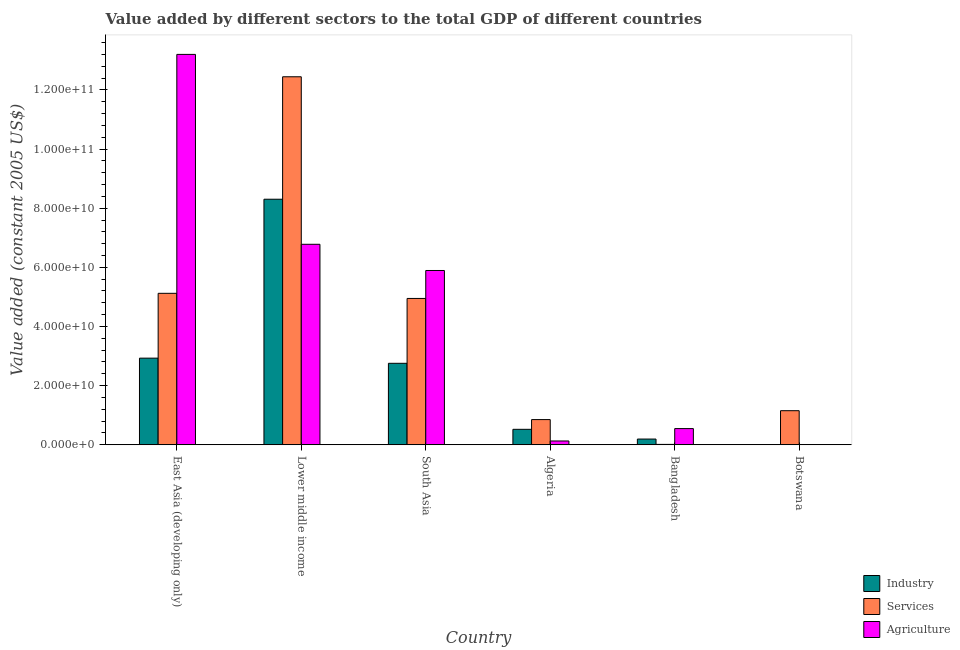How many groups of bars are there?
Make the answer very short. 6. Are the number of bars on each tick of the X-axis equal?
Your response must be concise. Yes. How many bars are there on the 6th tick from the left?
Keep it short and to the point. 3. What is the label of the 1st group of bars from the left?
Ensure brevity in your answer.  East Asia (developing only). In how many cases, is the number of bars for a given country not equal to the number of legend labels?
Make the answer very short. 0. What is the value added by services in South Asia?
Keep it short and to the point. 4.95e+1. Across all countries, what is the maximum value added by services?
Offer a terse response. 1.24e+11. Across all countries, what is the minimum value added by industrial sector?
Provide a succinct answer. 1.98e+07. In which country was the value added by industrial sector maximum?
Your answer should be very brief. Lower middle income. In which country was the value added by agricultural sector minimum?
Your response must be concise. Botswana. What is the total value added by industrial sector in the graph?
Offer a terse response. 1.47e+11. What is the difference between the value added by industrial sector in Lower middle income and that in South Asia?
Provide a succinct answer. 5.55e+1. What is the difference between the value added by services in East Asia (developing only) and the value added by agricultural sector in Botswana?
Keep it short and to the point. 5.12e+1. What is the average value added by services per country?
Ensure brevity in your answer.  4.09e+1. What is the difference between the value added by services and value added by industrial sector in Lower middle income?
Your answer should be very brief. 4.14e+1. What is the ratio of the value added by agricultural sector in Bangladesh to that in East Asia (developing only)?
Offer a very short reply. 0.04. Is the value added by services in Lower middle income less than that in South Asia?
Your answer should be compact. No. Is the difference between the value added by services in Bangladesh and East Asia (developing only) greater than the difference between the value added by industrial sector in Bangladesh and East Asia (developing only)?
Offer a very short reply. No. What is the difference between the highest and the second highest value added by industrial sector?
Keep it short and to the point. 5.37e+1. What is the difference between the highest and the lowest value added by services?
Your response must be concise. 1.24e+11. In how many countries, is the value added by industrial sector greater than the average value added by industrial sector taken over all countries?
Provide a succinct answer. 3. Is the sum of the value added by agricultural sector in Algeria and East Asia (developing only) greater than the maximum value added by services across all countries?
Provide a succinct answer. Yes. What does the 3rd bar from the left in East Asia (developing only) represents?
Your answer should be compact. Agriculture. What does the 3rd bar from the right in Lower middle income represents?
Your response must be concise. Industry. How many bars are there?
Make the answer very short. 18. Are all the bars in the graph horizontal?
Keep it short and to the point. No. How many countries are there in the graph?
Your answer should be compact. 6. What is the difference between two consecutive major ticks on the Y-axis?
Give a very brief answer. 2.00e+1. Are the values on the major ticks of Y-axis written in scientific E-notation?
Make the answer very short. Yes. Does the graph contain any zero values?
Offer a terse response. No. Where does the legend appear in the graph?
Ensure brevity in your answer.  Bottom right. How are the legend labels stacked?
Your response must be concise. Vertical. What is the title of the graph?
Offer a very short reply. Value added by different sectors to the total GDP of different countries. Does "Ages 15-20" appear as one of the legend labels in the graph?
Make the answer very short. No. What is the label or title of the Y-axis?
Ensure brevity in your answer.  Value added (constant 2005 US$). What is the Value added (constant 2005 US$) in Industry in East Asia (developing only)?
Your answer should be very brief. 2.93e+1. What is the Value added (constant 2005 US$) of Services in East Asia (developing only)?
Provide a succinct answer. 5.12e+1. What is the Value added (constant 2005 US$) in Agriculture in East Asia (developing only)?
Provide a short and direct response. 1.32e+11. What is the Value added (constant 2005 US$) of Industry in Lower middle income?
Provide a succinct answer. 8.30e+1. What is the Value added (constant 2005 US$) in Services in Lower middle income?
Ensure brevity in your answer.  1.24e+11. What is the Value added (constant 2005 US$) of Agriculture in Lower middle income?
Offer a terse response. 6.78e+1. What is the Value added (constant 2005 US$) of Industry in South Asia?
Your answer should be compact. 2.76e+1. What is the Value added (constant 2005 US$) in Services in South Asia?
Provide a short and direct response. 4.95e+1. What is the Value added (constant 2005 US$) in Agriculture in South Asia?
Give a very brief answer. 5.89e+1. What is the Value added (constant 2005 US$) in Industry in Algeria?
Make the answer very short. 5.23e+09. What is the Value added (constant 2005 US$) of Services in Algeria?
Your answer should be very brief. 8.52e+09. What is the Value added (constant 2005 US$) in Agriculture in Algeria?
Provide a short and direct response. 1.29e+09. What is the Value added (constant 2005 US$) in Industry in Bangladesh?
Your response must be concise. 1.94e+09. What is the Value added (constant 2005 US$) in Services in Bangladesh?
Your answer should be very brief. 1.32e+08. What is the Value added (constant 2005 US$) of Agriculture in Bangladesh?
Offer a terse response. 5.48e+09. What is the Value added (constant 2005 US$) in Industry in Botswana?
Give a very brief answer. 1.98e+07. What is the Value added (constant 2005 US$) of Services in Botswana?
Provide a short and direct response. 1.15e+1. What is the Value added (constant 2005 US$) in Agriculture in Botswana?
Keep it short and to the point. 5.04e+07. Across all countries, what is the maximum Value added (constant 2005 US$) of Industry?
Offer a very short reply. 8.30e+1. Across all countries, what is the maximum Value added (constant 2005 US$) of Services?
Keep it short and to the point. 1.24e+11. Across all countries, what is the maximum Value added (constant 2005 US$) in Agriculture?
Offer a terse response. 1.32e+11. Across all countries, what is the minimum Value added (constant 2005 US$) in Industry?
Your answer should be very brief. 1.98e+07. Across all countries, what is the minimum Value added (constant 2005 US$) of Services?
Your response must be concise. 1.32e+08. Across all countries, what is the minimum Value added (constant 2005 US$) of Agriculture?
Offer a very short reply. 5.04e+07. What is the total Value added (constant 2005 US$) of Industry in the graph?
Offer a very short reply. 1.47e+11. What is the total Value added (constant 2005 US$) in Services in the graph?
Provide a short and direct response. 2.45e+11. What is the total Value added (constant 2005 US$) in Agriculture in the graph?
Your answer should be very brief. 2.66e+11. What is the difference between the Value added (constant 2005 US$) of Industry in East Asia (developing only) and that in Lower middle income?
Ensure brevity in your answer.  -5.37e+1. What is the difference between the Value added (constant 2005 US$) of Services in East Asia (developing only) and that in Lower middle income?
Provide a short and direct response. -7.32e+1. What is the difference between the Value added (constant 2005 US$) in Agriculture in East Asia (developing only) and that in Lower middle income?
Your answer should be compact. 6.42e+1. What is the difference between the Value added (constant 2005 US$) in Industry in East Asia (developing only) and that in South Asia?
Make the answer very short. 1.74e+09. What is the difference between the Value added (constant 2005 US$) of Services in East Asia (developing only) and that in South Asia?
Keep it short and to the point. 1.74e+09. What is the difference between the Value added (constant 2005 US$) in Agriculture in East Asia (developing only) and that in South Asia?
Provide a short and direct response. 7.31e+1. What is the difference between the Value added (constant 2005 US$) in Industry in East Asia (developing only) and that in Algeria?
Offer a terse response. 2.41e+1. What is the difference between the Value added (constant 2005 US$) of Services in East Asia (developing only) and that in Algeria?
Your response must be concise. 4.27e+1. What is the difference between the Value added (constant 2005 US$) in Agriculture in East Asia (developing only) and that in Algeria?
Keep it short and to the point. 1.31e+11. What is the difference between the Value added (constant 2005 US$) of Industry in East Asia (developing only) and that in Bangladesh?
Offer a very short reply. 2.74e+1. What is the difference between the Value added (constant 2005 US$) of Services in East Asia (developing only) and that in Bangladesh?
Offer a very short reply. 5.11e+1. What is the difference between the Value added (constant 2005 US$) of Agriculture in East Asia (developing only) and that in Bangladesh?
Provide a short and direct response. 1.27e+11. What is the difference between the Value added (constant 2005 US$) in Industry in East Asia (developing only) and that in Botswana?
Offer a very short reply. 2.93e+1. What is the difference between the Value added (constant 2005 US$) of Services in East Asia (developing only) and that in Botswana?
Offer a very short reply. 3.97e+1. What is the difference between the Value added (constant 2005 US$) in Agriculture in East Asia (developing only) and that in Botswana?
Your answer should be very brief. 1.32e+11. What is the difference between the Value added (constant 2005 US$) in Industry in Lower middle income and that in South Asia?
Offer a very short reply. 5.55e+1. What is the difference between the Value added (constant 2005 US$) in Services in Lower middle income and that in South Asia?
Keep it short and to the point. 7.50e+1. What is the difference between the Value added (constant 2005 US$) of Agriculture in Lower middle income and that in South Asia?
Ensure brevity in your answer.  8.86e+09. What is the difference between the Value added (constant 2005 US$) in Industry in Lower middle income and that in Algeria?
Make the answer very short. 7.78e+1. What is the difference between the Value added (constant 2005 US$) of Services in Lower middle income and that in Algeria?
Offer a terse response. 1.16e+11. What is the difference between the Value added (constant 2005 US$) in Agriculture in Lower middle income and that in Algeria?
Offer a terse response. 6.65e+1. What is the difference between the Value added (constant 2005 US$) of Industry in Lower middle income and that in Bangladesh?
Ensure brevity in your answer.  8.11e+1. What is the difference between the Value added (constant 2005 US$) in Services in Lower middle income and that in Bangladesh?
Ensure brevity in your answer.  1.24e+11. What is the difference between the Value added (constant 2005 US$) of Agriculture in Lower middle income and that in Bangladesh?
Your response must be concise. 6.23e+1. What is the difference between the Value added (constant 2005 US$) of Industry in Lower middle income and that in Botswana?
Offer a terse response. 8.30e+1. What is the difference between the Value added (constant 2005 US$) in Services in Lower middle income and that in Botswana?
Your response must be concise. 1.13e+11. What is the difference between the Value added (constant 2005 US$) of Agriculture in Lower middle income and that in Botswana?
Provide a succinct answer. 6.77e+1. What is the difference between the Value added (constant 2005 US$) in Industry in South Asia and that in Algeria?
Offer a terse response. 2.23e+1. What is the difference between the Value added (constant 2005 US$) of Services in South Asia and that in Algeria?
Give a very brief answer. 4.10e+1. What is the difference between the Value added (constant 2005 US$) of Agriculture in South Asia and that in Algeria?
Provide a short and direct response. 5.76e+1. What is the difference between the Value added (constant 2005 US$) of Industry in South Asia and that in Bangladesh?
Keep it short and to the point. 2.56e+1. What is the difference between the Value added (constant 2005 US$) in Services in South Asia and that in Bangladesh?
Keep it short and to the point. 4.93e+1. What is the difference between the Value added (constant 2005 US$) of Agriculture in South Asia and that in Bangladesh?
Your answer should be compact. 5.35e+1. What is the difference between the Value added (constant 2005 US$) in Industry in South Asia and that in Botswana?
Your answer should be compact. 2.75e+1. What is the difference between the Value added (constant 2005 US$) of Services in South Asia and that in Botswana?
Offer a very short reply. 3.80e+1. What is the difference between the Value added (constant 2005 US$) in Agriculture in South Asia and that in Botswana?
Keep it short and to the point. 5.89e+1. What is the difference between the Value added (constant 2005 US$) in Industry in Algeria and that in Bangladesh?
Your response must be concise. 3.29e+09. What is the difference between the Value added (constant 2005 US$) of Services in Algeria and that in Bangladesh?
Provide a succinct answer. 8.39e+09. What is the difference between the Value added (constant 2005 US$) in Agriculture in Algeria and that in Bangladesh?
Ensure brevity in your answer.  -4.19e+09. What is the difference between the Value added (constant 2005 US$) of Industry in Algeria and that in Botswana?
Ensure brevity in your answer.  5.21e+09. What is the difference between the Value added (constant 2005 US$) in Services in Algeria and that in Botswana?
Make the answer very short. -3.00e+09. What is the difference between the Value added (constant 2005 US$) in Agriculture in Algeria and that in Botswana?
Your response must be concise. 1.24e+09. What is the difference between the Value added (constant 2005 US$) of Industry in Bangladesh and that in Botswana?
Your answer should be compact. 1.92e+09. What is the difference between the Value added (constant 2005 US$) of Services in Bangladesh and that in Botswana?
Keep it short and to the point. -1.14e+1. What is the difference between the Value added (constant 2005 US$) in Agriculture in Bangladesh and that in Botswana?
Your answer should be very brief. 5.43e+09. What is the difference between the Value added (constant 2005 US$) of Industry in East Asia (developing only) and the Value added (constant 2005 US$) of Services in Lower middle income?
Provide a short and direct response. -9.51e+1. What is the difference between the Value added (constant 2005 US$) in Industry in East Asia (developing only) and the Value added (constant 2005 US$) in Agriculture in Lower middle income?
Your answer should be compact. -3.85e+1. What is the difference between the Value added (constant 2005 US$) in Services in East Asia (developing only) and the Value added (constant 2005 US$) in Agriculture in Lower middle income?
Ensure brevity in your answer.  -1.66e+1. What is the difference between the Value added (constant 2005 US$) in Industry in East Asia (developing only) and the Value added (constant 2005 US$) in Services in South Asia?
Ensure brevity in your answer.  -2.02e+1. What is the difference between the Value added (constant 2005 US$) of Industry in East Asia (developing only) and the Value added (constant 2005 US$) of Agriculture in South Asia?
Your response must be concise. -2.96e+1. What is the difference between the Value added (constant 2005 US$) in Services in East Asia (developing only) and the Value added (constant 2005 US$) in Agriculture in South Asia?
Make the answer very short. -7.71e+09. What is the difference between the Value added (constant 2005 US$) in Industry in East Asia (developing only) and the Value added (constant 2005 US$) in Services in Algeria?
Ensure brevity in your answer.  2.08e+1. What is the difference between the Value added (constant 2005 US$) of Industry in East Asia (developing only) and the Value added (constant 2005 US$) of Agriculture in Algeria?
Provide a succinct answer. 2.80e+1. What is the difference between the Value added (constant 2005 US$) of Services in East Asia (developing only) and the Value added (constant 2005 US$) of Agriculture in Algeria?
Provide a succinct answer. 4.99e+1. What is the difference between the Value added (constant 2005 US$) in Industry in East Asia (developing only) and the Value added (constant 2005 US$) in Services in Bangladesh?
Your response must be concise. 2.92e+1. What is the difference between the Value added (constant 2005 US$) in Industry in East Asia (developing only) and the Value added (constant 2005 US$) in Agriculture in Bangladesh?
Your answer should be very brief. 2.38e+1. What is the difference between the Value added (constant 2005 US$) in Services in East Asia (developing only) and the Value added (constant 2005 US$) in Agriculture in Bangladesh?
Your answer should be compact. 4.57e+1. What is the difference between the Value added (constant 2005 US$) in Industry in East Asia (developing only) and the Value added (constant 2005 US$) in Services in Botswana?
Give a very brief answer. 1.78e+1. What is the difference between the Value added (constant 2005 US$) in Industry in East Asia (developing only) and the Value added (constant 2005 US$) in Agriculture in Botswana?
Make the answer very short. 2.92e+1. What is the difference between the Value added (constant 2005 US$) in Services in East Asia (developing only) and the Value added (constant 2005 US$) in Agriculture in Botswana?
Your answer should be very brief. 5.12e+1. What is the difference between the Value added (constant 2005 US$) in Industry in Lower middle income and the Value added (constant 2005 US$) in Services in South Asia?
Offer a terse response. 3.35e+1. What is the difference between the Value added (constant 2005 US$) of Industry in Lower middle income and the Value added (constant 2005 US$) of Agriculture in South Asia?
Offer a terse response. 2.41e+1. What is the difference between the Value added (constant 2005 US$) in Services in Lower middle income and the Value added (constant 2005 US$) in Agriculture in South Asia?
Provide a succinct answer. 6.55e+1. What is the difference between the Value added (constant 2005 US$) of Industry in Lower middle income and the Value added (constant 2005 US$) of Services in Algeria?
Keep it short and to the point. 7.45e+1. What is the difference between the Value added (constant 2005 US$) of Industry in Lower middle income and the Value added (constant 2005 US$) of Agriculture in Algeria?
Keep it short and to the point. 8.17e+1. What is the difference between the Value added (constant 2005 US$) in Services in Lower middle income and the Value added (constant 2005 US$) in Agriculture in Algeria?
Provide a succinct answer. 1.23e+11. What is the difference between the Value added (constant 2005 US$) in Industry in Lower middle income and the Value added (constant 2005 US$) in Services in Bangladesh?
Offer a terse response. 8.29e+1. What is the difference between the Value added (constant 2005 US$) in Industry in Lower middle income and the Value added (constant 2005 US$) in Agriculture in Bangladesh?
Offer a very short reply. 7.76e+1. What is the difference between the Value added (constant 2005 US$) in Services in Lower middle income and the Value added (constant 2005 US$) in Agriculture in Bangladesh?
Give a very brief answer. 1.19e+11. What is the difference between the Value added (constant 2005 US$) of Industry in Lower middle income and the Value added (constant 2005 US$) of Services in Botswana?
Ensure brevity in your answer.  7.15e+1. What is the difference between the Value added (constant 2005 US$) of Industry in Lower middle income and the Value added (constant 2005 US$) of Agriculture in Botswana?
Give a very brief answer. 8.30e+1. What is the difference between the Value added (constant 2005 US$) of Services in Lower middle income and the Value added (constant 2005 US$) of Agriculture in Botswana?
Provide a succinct answer. 1.24e+11. What is the difference between the Value added (constant 2005 US$) of Industry in South Asia and the Value added (constant 2005 US$) of Services in Algeria?
Provide a short and direct response. 1.90e+1. What is the difference between the Value added (constant 2005 US$) in Industry in South Asia and the Value added (constant 2005 US$) in Agriculture in Algeria?
Give a very brief answer. 2.63e+1. What is the difference between the Value added (constant 2005 US$) in Services in South Asia and the Value added (constant 2005 US$) in Agriculture in Algeria?
Give a very brief answer. 4.82e+1. What is the difference between the Value added (constant 2005 US$) in Industry in South Asia and the Value added (constant 2005 US$) in Services in Bangladesh?
Make the answer very short. 2.74e+1. What is the difference between the Value added (constant 2005 US$) of Industry in South Asia and the Value added (constant 2005 US$) of Agriculture in Bangladesh?
Your answer should be very brief. 2.21e+1. What is the difference between the Value added (constant 2005 US$) in Services in South Asia and the Value added (constant 2005 US$) in Agriculture in Bangladesh?
Keep it short and to the point. 4.40e+1. What is the difference between the Value added (constant 2005 US$) in Industry in South Asia and the Value added (constant 2005 US$) in Services in Botswana?
Provide a succinct answer. 1.60e+1. What is the difference between the Value added (constant 2005 US$) in Industry in South Asia and the Value added (constant 2005 US$) in Agriculture in Botswana?
Your response must be concise. 2.75e+1. What is the difference between the Value added (constant 2005 US$) of Services in South Asia and the Value added (constant 2005 US$) of Agriculture in Botswana?
Provide a short and direct response. 4.94e+1. What is the difference between the Value added (constant 2005 US$) of Industry in Algeria and the Value added (constant 2005 US$) of Services in Bangladesh?
Offer a terse response. 5.10e+09. What is the difference between the Value added (constant 2005 US$) in Industry in Algeria and the Value added (constant 2005 US$) in Agriculture in Bangladesh?
Ensure brevity in your answer.  -2.48e+08. What is the difference between the Value added (constant 2005 US$) of Services in Algeria and the Value added (constant 2005 US$) of Agriculture in Bangladesh?
Make the answer very short. 3.04e+09. What is the difference between the Value added (constant 2005 US$) in Industry in Algeria and the Value added (constant 2005 US$) in Services in Botswana?
Give a very brief answer. -6.30e+09. What is the difference between the Value added (constant 2005 US$) of Industry in Algeria and the Value added (constant 2005 US$) of Agriculture in Botswana?
Offer a terse response. 5.18e+09. What is the difference between the Value added (constant 2005 US$) of Services in Algeria and the Value added (constant 2005 US$) of Agriculture in Botswana?
Provide a succinct answer. 8.47e+09. What is the difference between the Value added (constant 2005 US$) of Industry in Bangladesh and the Value added (constant 2005 US$) of Services in Botswana?
Make the answer very short. -9.59e+09. What is the difference between the Value added (constant 2005 US$) of Industry in Bangladesh and the Value added (constant 2005 US$) of Agriculture in Botswana?
Keep it short and to the point. 1.89e+09. What is the difference between the Value added (constant 2005 US$) of Services in Bangladesh and the Value added (constant 2005 US$) of Agriculture in Botswana?
Keep it short and to the point. 8.19e+07. What is the average Value added (constant 2005 US$) of Industry per country?
Your answer should be compact. 2.45e+1. What is the average Value added (constant 2005 US$) in Services per country?
Offer a very short reply. 4.09e+1. What is the average Value added (constant 2005 US$) of Agriculture per country?
Keep it short and to the point. 4.43e+1. What is the difference between the Value added (constant 2005 US$) in Industry and Value added (constant 2005 US$) in Services in East Asia (developing only)?
Your answer should be compact. -2.19e+1. What is the difference between the Value added (constant 2005 US$) in Industry and Value added (constant 2005 US$) in Agriculture in East Asia (developing only)?
Your response must be concise. -1.03e+11. What is the difference between the Value added (constant 2005 US$) of Services and Value added (constant 2005 US$) of Agriculture in East Asia (developing only)?
Give a very brief answer. -8.08e+1. What is the difference between the Value added (constant 2005 US$) of Industry and Value added (constant 2005 US$) of Services in Lower middle income?
Your response must be concise. -4.14e+1. What is the difference between the Value added (constant 2005 US$) in Industry and Value added (constant 2005 US$) in Agriculture in Lower middle income?
Your answer should be compact. 1.52e+1. What is the difference between the Value added (constant 2005 US$) of Services and Value added (constant 2005 US$) of Agriculture in Lower middle income?
Your answer should be compact. 5.66e+1. What is the difference between the Value added (constant 2005 US$) in Industry and Value added (constant 2005 US$) in Services in South Asia?
Ensure brevity in your answer.  -2.19e+1. What is the difference between the Value added (constant 2005 US$) of Industry and Value added (constant 2005 US$) of Agriculture in South Asia?
Your answer should be very brief. -3.14e+1. What is the difference between the Value added (constant 2005 US$) of Services and Value added (constant 2005 US$) of Agriculture in South Asia?
Give a very brief answer. -9.45e+09. What is the difference between the Value added (constant 2005 US$) of Industry and Value added (constant 2005 US$) of Services in Algeria?
Make the answer very short. -3.29e+09. What is the difference between the Value added (constant 2005 US$) in Industry and Value added (constant 2005 US$) in Agriculture in Algeria?
Your answer should be very brief. 3.94e+09. What is the difference between the Value added (constant 2005 US$) in Services and Value added (constant 2005 US$) in Agriculture in Algeria?
Offer a terse response. 7.23e+09. What is the difference between the Value added (constant 2005 US$) of Industry and Value added (constant 2005 US$) of Services in Bangladesh?
Your response must be concise. 1.81e+09. What is the difference between the Value added (constant 2005 US$) in Industry and Value added (constant 2005 US$) in Agriculture in Bangladesh?
Give a very brief answer. -3.54e+09. What is the difference between the Value added (constant 2005 US$) of Services and Value added (constant 2005 US$) of Agriculture in Bangladesh?
Make the answer very short. -5.35e+09. What is the difference between the Value added (constant 2005 US$) in Industry and Value added (constant 2005 US$) in Services in Botswana?
Your answer should be compact. -1.15e+1. What is the difference between the Value added (constant 2005 US$) in Industry and Value added (constant 2005 US$) in Agriculture in Botswana?
Offer a very short reply. -3.05e+07. What is the difference between the Value added (constant 2005 US$) in Services and Value added (constant 2005 US$) in Agriculture in Botswana?
Offer a very short reply. 1.15e+1. What is the ratio of the Value added (constant 2005 US$) of Industry in East Asia (developing only) to that in Lower middle income?
Offer a very short reply. 0.35. What is the ratio of the Value added (constant 2005 US$) of Services in East Asia (developing only) to that in Lower middle income?
Your response must be concise. 0.41. What is the ratio of the Value added (constant 2005 US$) in Agriculture in East Asia (developing only) to that in Lower middle income?
Your response must be concise. 1.95. What is the ratio of the Value added (constant 2005 US$) in Industry in East Asia (developing only) to that in South Asia?
Ensure brevity in your answer.  1.06. What is the ratio of the Value added (constant 2005 US$) in Services in East Asia (developing only) to that in South Asia?
Provide a succinct answer. 1.04. What is the ratio of the Value added (constant 2005 US$) in Agriculture in East Asia (developing only) to that in South Asia?
Make the answer very short. 2.24. What is the ratio of the Value added (constant 2005 US$) of Industry in East Asia (developing only) to that in Algeria?
Give a very brief answer. 5.6. What is the ratio of the Value added (constant 2005 US$) in Services in East Asia (developing only) to that in Algeria?
Provide a short and direct response. 6.01. What is the ratio of the Value added (constant 2005 US$) of Agriculture in East Asia (developing only) to that in Algeria?
Provide a succinct answer. 102.31. What is the ratio of the Value added (constant 2005 US$) of Industry in East Asia (developing only) to that in Bangladesh?
Provide a succinct answer. 15.11. What is the ratio of the Value added (constant 2005 US$) of Services in East Asia (developing only) to that in Bangladesh?
Your answer should be compact. 387.2. What is the ratio of the Value added (constant 2005 US$) of Agriculture in East Asia (developing only) to that in Bangladesh?
Your response must be concise. 24.09. What is the ratio of the Value added (constant 2005 US$) of Industry in East Asia (developing only) to that in Botswana?
Make the answer very short. 1477.51. What is the ratio of the Value added (constant 2005 US$) in Services in East Asia (developing only) to that in Botswana?
Your response must be concise. 4.44. What is the ratio of the Value added (constant 2005 US$) in Agriculture in East Asia (developing only) to that in Botswana?
Offer a very short reply. 2620.64. What is the ratio of the Value added (constant 2005 US$) of Industry in Lower middle income to that in South Asia?
Offer a terse response. 3.01. What is the ratio of the Value added (constant 2005 US$) in Services in Lower middle income to that in South Asia?
Your answer should be compact. 2.51. What is the ratio of the Value added (constant 2005 US$) in Agriculture in Lower middle income to that in South Asia?
Make the answer very short. 1.15. What is the ratio of the Value added (constant 2005 US$) in Industry in Lower middle income to that in Algeria?
Provide a succinct answer. 15.87. What is the ratio of the Value added (constant 2005 US$) in Services in Lower middle income to that in Algeria?
Give a very brief answer. 14.6. What is the ratio of the Value added (constant 2005 US$) in Agriculture in Lower middle income to that in Algeria?
Provide a short and direct response. 52.55. What is the ratio of the Value added (constant 2005 US$) of Industry in Lower middle income to that in Bangladesh?
Give a very brief answer. 42.83. What is the ratio of the Value added (constant 2005 US$) of Services in Lower middle income to that in Bangladesh?
Provide a short and direct response. 940.71. What is the ratio of the Value added (constant 2005 US$) of Agriculture in Lower middle income to that in Bangladesh?
Your answer should be very brief. 12.37. What is the ratio of the Value added (constant 2005 US$) of Industry in Lower middle income to that in Botswana?
Offer a terse response. 4187.65. What is the ratio of the Value added (constant 2005 US$) of Services in Lower middle income to that in Botswana?
Provide a short and direct response. 10.79. What is the ratio of the Value added (constant 2005 US$) of Agriculture in Lower middle income to that in Botswana?
Keep it short and to the point. 1345.99. What is the ratio of the Value added (constant 2005 US$) of Industry in South Asia to that in Algeria?
Keep it short and to the point. 5.27. What is the ratio of the Value added (constant 2005 US$) in Services in South Asia to that in Algeria?
Make the answer very short. 5.81. What is the ratio of the Value added (constant 2005 US$) of Agriculture in South Asia to that in Algeria?
Offer a very short reply. 45.68. What is the ratio of the Value added (constant 2005 US$) of Industry in South Asia to that in Bangladesh?
Provide a short and direct response. 14.21. What is the ratio of the Value added (constant 2005 US$) of Services in South Asia to that in Bangladesh?
Provide a short and direct response. 374.08. What is the ratio of the Value added (constant 2005 US$) in Agriculture in South Asia to that in Bangladesh?
Provide a short and direct response. 10.75. What is the ratio of the Value added (constant 2005 US$) in Industry in South Asia to that in Botswana?
Your answer should be compact. 1389.51. What is the ratio of the Value added (constant 2005 US$) in Services in South Asia to that in Botswana?
Offer a terse response. 4.29. What is the ratio of the Value added (constant 2005 US$) of Agriculture in South Asia to that in Botswana?
Provide a short and direct response. 1170. What is the ratio of the Value added (constant 2005 US$) in Industry in Algeria to that in Bangladesh?
Give a very brief answer. 2.7. What is the ratio of the Value added (constant 2005 US$) in Services in Algeria to that in Bangladesh?
Offer a terse response. 64.43. What is the ratio of the Value added (constant 2005 US$) in Agriculture in Algeria to that in Bangladesh?
Offer a very short reply. 0.24. What is the ratio of the Value added (constant 2005 US$) of Industry in Algeria to that in Botswana?
Offer a terse response. 263.85. What is the ratio of the Value added (constant 2005 US$) in Services in Algeria to that in Botswana?
Your response must be concise. 0.74. What is the ratio of the Value added (constant 2005 US$) of Agriculture in Algeria to that in Botswana?
Give a very brief answer. 25.62. What is the ratio of the Value added (constant 2005 US$) in Industry in Bangladesh to that in Botswana?
Offer a terse response. 97.78. What is the ratio of the Value added (constant 2005 US$) in Services in Bangladesh to that in Botswana?
Give a very brief answer. 0.01. What is the ratio of the Value added (constant 2005 US$) in Agriculture in Bangladesh to that in Botswana?
Provide a succinct answer. 108.79. What is the difference between the highest and the second highest Value added (constant 2005 US$) in Industry?
Offer a very short reply. 5.37e+1. What is the difference between the highest and the second highest Value added (constant 2005 US$) in Services?
Keep it short and to the point. 7.32e+1. What is the difference between the highest and the second highest Value added (constant 2005 US$) of Agriculture?
Provide a succinct answer. 6.42e+1. What is the difference between the highest and the lowest Value added (constant 2005 US$) of Industry?
Make the answer very short. 8.30e+1. What is the difference between the highest and the lowest Value added (constant 2005 US$) in Services?
Offer a very short reply. 1.24e+11. What is the difference between the highest and the lowest Value added (constant 2005 US$) in Agriculture?
Provide a succinct answer. 1.32e+11. 